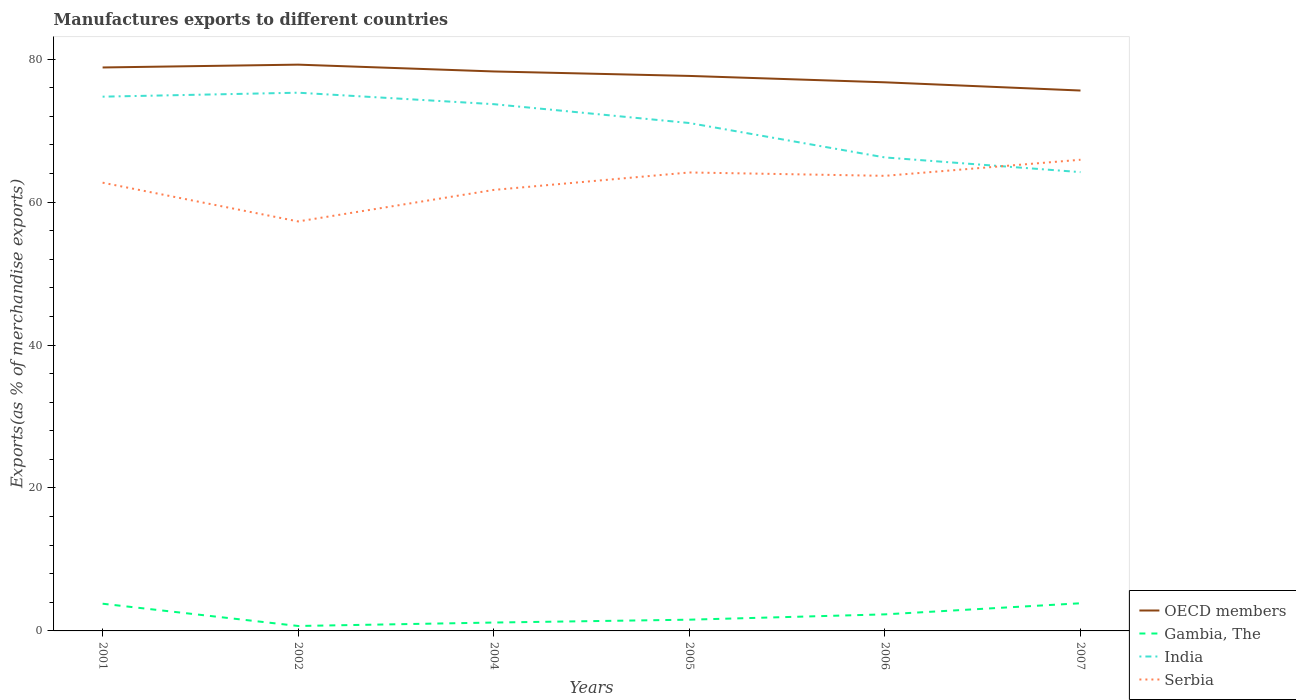Does the line corresponding to Gambia, The intersect with the line corresponding to OECD members?
Your answer should be very brief. No. Across all years, what is the maximum percentage of exports to different countries in India?
Offer a terse response. 64.2. In which year was the percentage of exports to different countries in Serbia maximum?
Keep it short and to the point. 2002. What is the total percentage of exports to different countries in Serbia in the graph?
Provide a succinct answer. -6.38. What is the difference between the highest and the second highest percentage of exports to different countries in Serbia?
Your response must be concise. 8.63. What is the difference between the highest and the lowest percentage of exports to different countries in OECD members?
Make the answer very short. 3. What is the difference between two consecutive major ticks on the Y-axis?
Give a very brief answer. 20. Are the values on the major ticks of Y-axis written in scientific E-notation?
Ensure brevity in your answer.  No. Does the graph contain any zero values?
Offer a very short reply. No. Where does the legend appear in the graph?
Keep it short and to the point. Bottom right. How many legend labels are there?
Keep it short and to the point. 4. What is the title of the graph?
Offer a very short reply. Manufactures exports to different countries. What is the label or title of the X-axis?
Your answer should be very brief. Years. What is the label or title of the Y-axis?
Give a very brief answer. Exports(as % of merchandise exports). What is the Exports(as % of merchandise exports) of OECD members in 2001?
Offer a very short reply. 78.85. What is the Exports(as % of merchandise exports) of Gambia, The in 2001?
Offer a terse response. 3.81. What is the Exports(as % of merchandise exports) of India in 2001?
Give a very brief answer. 74.76. What is the Exports(as % of merchandise exports) in Serbia in 2001?
Keep it short and to the point. 62.73. What is the Exports(as % of merchandise exports) of OECD members in 2002?
Make the answer very short. 79.24. What is the Exports(as % of merchandise exports) of Gambia, The in 2002?
Ensure brevity in your answer.  0.69. What is the Exports(as % of merchandise exports) in India in 2002?
Your answer should be compact. 75.32. What is the Exports(as % of merchandise exports) of Serbia in 2002?
Provide a short and direct response. 57.3. What is the Exports(as % of merchandise exports) of OECD members in 2004?
Your answer should be compact. 78.29. What is the Exports(as % of merchandise exports) in Gambia, The in 2004?
Provide a succinct answer. 1.17. What is the Exports(as % of merchandise exports) of India in 2004?
Offer a very short reply. 73.71. What is the Exports(as % of merchandise exports) of Serbia in 2004?
Keep it short and to the point. 61.71. What is the Exports(as % of merchandise exports) of OECD members in 2005?
Keep it short and to the point. 77.67. What is the Exports(as % of merchandise exports) of Gambia, The in 2005?
Your answer should be very brief. 1.57. What is the Exports(as % of merchandise exports) in India in 2005?
Give a very brief answer. 71.07. What is the Exports(as % of merchandise exports) in Serbia in 2005?
Ensure brevity in your answer.  64.15. What is the Exports(as % of merchandise exports) of OECD members in 2006?
Your answer should be compact. 76.77. What is the Exports(as % of merchandise exports) of Gambia, The in 2006?
Ensure brevity in your answer.  2.32. What is the Exports(as % of merchandise exports) in India in 2006?
Your answer should be very brief. 66.26. What is the Exports(as % of merchandise exports) of Serbia in 2006?
Give a very brief answer. 63.68. What is the Exports(as % of merchandise exports) in OECD members in 2007?
Offer a very short reply. 75.62. What is the Exports(as % of merchandise exports) of Gambia, The in 2007?
Ensure brevity in your answer.  3.87. What is the Exports(as % of merchandise exports) in India in 2007?
Your answer should be compact. 64.2. What is the Exports(as % of merchandise exports) in Serbia in 2007?
Make the answer very short. 65.93. Across all years, what is the maximum Exports(as % of merchandise exports) in OECD members?
Ensure brevity in your answer.  79.24. Across all years, what is the maximum Exports(as % of merchandise exports) in Gambia, The?
Your answer should be compact. 3.87. Across all years, what is the maximum Exports(as % of merchandise exports) in India?
Make the answer very short. 75.32. Across all years, what is the maximum Exports(as % of merchandise exports) in Serbia?
Give a very brief answer. 65.93. Across all years, what is the minimum Exports(as % of merchandise exports) in OECD members?
Provide a short and direct response. 75.62. Across all years, what is the minimum Exports(as % of merchandise exports) of Gambia, The?
Offer a terse response. 0.69. Across all years, what is the minimum Exports(as % of merchandise exports) in India?
Ensure brevity in your answer.  64.2. Across all years, what is the minimum Exports(as % of merchandise exports) in Serbia?
Provide a short and direct response. 57.3. What is the total Exports(as % of merchandise exports) in OECD members in the graph?
Ensure brevity in your answer.  466.44. What is the total Exports(as % of merchandise exports) in Gambia, The in the graph?
Keep it short and to the point. 13.43. What is the total Exports(as % of merchandise exports) of India in the graph?
Your answer should be compact. 425.32. What is the total Exports(as % of merchandise exports) in Serbia in the graph?
Make the answer very short. 375.51. What is the difference between the Exports(as % of merchandise exports) of OECD members in 2001 and that in 2002?
Provide a succinct answer. -0.4. What is the difference between the Exports(as % of merchandise exports) in Gambia, The in 2001 and that in 2002?
Provide a succinct answer. 3.12. What is the difference between the Exports(as % of merchandise exports) in India in 2001 and that in 2002?
Provide a succinct answer. -0.56. What is the difference between the Exports(as % of merchandise exports) of Serbia in 2001 and that in 2002?
Your answer should be very brief. 5.42. What is the difference between the Exports(as % of merchandise exports) in OECD members in 2001 and that in 2004?
Offer a terse response. 0.56. What is the difference between the Exports(as % of merchandise exports) in Gambia, The in 2001 and that in 2004?
Provide a succinct answer. 2.63. What is the difference between the Exports(as % of merchandise exports) of India in 2001 and that in 2004?
Give a very brief answer. 1.05. What is the difference between the Exports(as % of merchandise exports) in Serbia in 2001 and that in 2004?
Provide a succinct answer. 1.01. What is the difference between the Exports(as % of merchandise exports) in OECD members in 2001 and that in 2005?
Offer a terse response. 1.18. What is the difference between the Exports(as % of merchandise exports) in Gambia, The in 2001 and that in 2005?
Your answer should be very brief. 2.23. What is the difference between the Exports(as % of merchandise exports) in India in 2001 and that in 2005?
Provide a succinct answer. 3.69. What is the difference between the Exports(as % of merchandise exports) of Serbia in 2001 and that in 2005?
Make the answer very short. -1.43. What is the difference between the Exports(as % of merchandise exports) in OECD members in 2001 and that in 2006?
Give a very brief answer. 2.08. What is the difference between the Exports(as % of merchandise exports) of Gambia, The in 2001 and that in 2006?
Your response must be concise. 1.49. What is the difference between the Exports(as % of merchandise exports) in India in 2001 and that in 2006?
Provide a short and direct response. 8.5. What is the difference between the Exports(as % of merchandise exports) of Serbia in 2001 and that in 2006?
Your answer should be very brief. -0.96. What is the difference between the Exports(as % of merchandise exports) in OECD members in 2001 and that in 2007?
Offer a very short reply. 3.23. What is the difference between the Exports(as % of merchandise exports) in Gambia, The in 2001 and that in 2007?
Ensure brevity in your answer.  -0.06. What is the difference between the Exports(as % of merchandise exports) of India in 2001 and that in 2007?
Provide a succinct answer. 10.56. What is the difference between the Exports(as % of merchandise exports) of Serbia in 2001 and that in 2007?
Provide a short and direct response. -3.21. What is the difference between the Exports(as % of merchandise exports) of OECD members in 2002 and that in 2004?
Give a very brief answer. 0.95. What is the difference between the Exports(as % of merchandise exports) in Gambia, The in 2002 and that in 2004?
Provide a succinct answer. -0.48. What is the difference between the Exports(as % of merchandise exports) of India in 2002 and that in 2004?
Make the answer very short. 1.61. What is the difference between the Exports(as % of merchandise exports) in Serbia in 2002 and that in 2004?
Your response must be concise. -4.41. What is the difference between the Exports(as % of merchandise exports) in OECD members in 2002 and that in 2005?
Your answer should be very brief. 1.58. What is the difference between the Exports(as % of merchandise exports) in Gambia, The in 2002 and that in 2005?
Give a very brief answer. -0.88. What is the difference between the Exports(as % of merchandise exports) of India in 2002 and that in 2005?
Give a very brief answer. 4.24. What is the difference between the Exports(as % of merchandise exports) of Serbia in 2002 and that in 2005?
Your answer should be compact. -6.85. What is the difference between the Exports(as % of merchandise exports) in OECD members in 2002 and that in 2006?
Keep it short and to the point. 2.47. What is the difference between the Exports(as % of merchandise exports) of Gambia, The in 2002 and that in 2006?
Your answer should be very brief. -1.63. What is the difference between the Exports(as % of merchandise exports) in India in 2002 and that in 2006?
Your answer should be very brief. 9.06. What is the difference between the Exports(as % of merchandise exports) of Serbia in 2002 and that in 2006?
Your answer should be very brief. -6.38. What is the difference between the Exports(as % of merchandise exports) in OECD members in 2002 and that in 2007?
Your answer should be compact. 3.62. What is the difference between the Exports(as % of merchandise exports) of Gambia, The in 2002 and that in 2007?
Provide a succinct answer. -3.18. What is the difference between the Exports(as % of merchandise exports) of India in 2002 and that in 2007?
Ensure brevity in your answer.  11.11. What is the difference between the Exports(as % of merchandise exports) of Serbia in 2002 and that in 2007?
Provide a short and direct response. -8.63. What is the difference between the Exports(as % of merchandise exports) in OECD members in 2004 and that in 2005?
Your answer should be compact. 0.62. What is the difference between the Exports(as % of merchandise exports) in Gambia, The in 2004 and that in 2005?
Make the answer very short. -0.4. What is the difference between the Exports(as % of merchandise exports) in India in 2004 and that in 2005?
Keep it short and to the point. 2.64. What is the difference between the Exports(as % of merchandise exports) of Serbia in 2004 and that in 2005?
Offer a terse response. -2.44. What is the difference between the Exports(as % of merchandise exports) of OECD members in 2004 and that in 2006?
Offer a very short reply. 1.52. What is the difference between the Exports(as % of merchandise exports) in Gambia, The in 2004 and that in 2006?
Provide a short and direct response. -1.15. What is the difference between the Exports(as % of merchandise exports) in India in 2004 and that in 2006?
Offer a very short reply. 7.45. What is the difference between the Exports(as % of merchandise exports) of Serbia in 2004 and that in 2006?
Offer a terse response. -1.97. What is the difference between the Exports(as % of merchandise exports) in OECD members in 2004 and that in 2007?
Your answer should be compact. 2.67. What is the difference between the Exports(as % of merchandise exports) in Gambia, The in 2004 and that in 2007?
Ensure brevity in your answer.  -2.7. What is the difference between the Exports(as % of merchandise exports) in India in 2004 and that in 2007?
Your answer should be compact. 9.51. What is the difference between the Exports(as % of merchandise exports) in Serbia in 2004 and that in 2007?
Offer a terse response. -4.22. What is the difference between the Exports(as % of merchandise exports) in OECD members in 2005 and that in 2006?
Your response must be concise. 0.89. What is the difference between the Exports(as % of merchandise exports) in Gambia, The in 2005 and that in 2006?
Make the answer very short. -0.75. What is the difference between the Exports(as % of merchandise exports) in India in 2005 and that in 2006?
Make the answer very short. 4.82. What is the difference between the Exports(as % of merchandise exports) in Serbia in 2005 and that in 2006?
Your answer should be compact. 0.47. What is the difference between the Exports(as % of merchandise exports) in OECD members in 2005 and that in 2007?
Your answer should be very brief. 2.04. What is the difference between the Exports(as % of merchandise exports) in Gambia, The in 2005 and that in 2007?
Your response must be concise. -2.3. What is the difference between the Exports(as % of merchandise exports) of India in 2005 and that in 2007?
Ensure brevity in your answer.  6.87. What is the difference between the Exports(as % of merchandise exports) of Serbia in 2005 and that in 2007?
Keep it short and to the point. -1.78. What is the difference between the Exports(as % of merchandise exports) in OECD members in 2006 and that in 2007?
Keep it short and to the point. 1.15. What is the difference between the Exports(as % of merchandise exports) of Gambia, The in 2006 and that in 2007?
Your answer should be very brief. -1.55. What is the difference between the Exports(as % of merchandise exports) of India in 2006 and that in 2007?
Keep it short and to the point. 2.05. What is the difference between the Exports(as % of merchandise exports) in Serbia in 2006 and that in 2007?
Ensure brevity in your answer.  -2.25. What is the difference between the Exports(as % of merchandise exports) in OECD members in 2001 and the Exports(as % of merchandise exports) in Gambia, The in 2002?
Provide a short and direct response. 78.16. What is the difference between the Exports(as % of merchandise exports) of OECD members in 2001 and the Exports(as % of merchandise exports) of India in 2002?
Provide a succinct answer. 3.53. What is the difference between the Exports(as % of merchandise exports) in OECD members in 2001 and the Exports(as % of merchandise exports) in Serbia in 2002?
Ensure brevity in your answer.  21.54. What is the difference between the Exports(as % of merchandise exports) in Gambia, The in 2001 and the Exports(as % of merchandise exports) in India in 2002?
Provide a succinct answer. -71.51. What is the difference between the Exports(as % of merchandise exports) of Gambia, The in 2001 and the Exports(as % of merchandise exports) of Serbia in 2002?
Give a very brief answer. -53.5. What is the difference between the Exports(as % of merchandise exports) in India in 2001 and the Exports(as % of merchandise exports) in Serbia in 2002?
Keep it short and to the point. 17.46. What is the difference between the Exports(as % of merchandise exports) in OECD members in 2001 and the Exports(as % of merchandise exports) in Gambia, The in 2004?
Provide a succinct answer. 77.67. What is the difference between the Exports(as % of merchandise exports) in OECD members in 2001 and the Exports(as % of merchandise exports) in India in 2004?
Your response must be concise. 5.13. What is the difference between the Exports(as % of merchandise exports) in OECD members in 2001 and the Exports(as % of merchandise exports) in Serbia in 2004?
Provide a short and direct response. 17.13. What is the difference between the Exports(as % of merchandise exports) in Gambia, The in 2001 and the Exports(as % of merchandise exports) in India in 2004?
Your answer should be compact. -69.9. What is the difference between the Exports(as % of merchandise exports) in Gambia, The in 2001 and the Exports(as % of merchandise exports) in Serbia in 2004?
Your answer should be compact. -57.91. What is the difference between the Exports(as % of merchandise exports) in India in 2001 and the Exports(as % of merchandise exports) in Serbia in 2004?
Offer a very short reply. 13.05. What is the difference between the Exports(as % of merchandise exports) in OECD members in 2001 and the Exports(as % of merchandise exports) in Gambia, The in 2005?
Keep it short and to the point. 77.27. What is the difference between the Exports(as % of merchandise exports) in OECD members in 2001 and the Exports(as % of merchandise exports) in India in 2005?
Provide a short and direct response. 7.77. What is the difference between the Exports(as % of merchandise exports) of OECD members in 2001 and the Exports(as % of merchandise exports) of Serbia in 2005?
Give a very brief answer. 14.69. What is the difference between the Exports(as % of merchandise exports) in Gambia, The in 2001 and the Exports(as % of merchandise exports) in India in 2005?
Offer a terse response. -67.27. What is the difference between the Exports(as % of merchandise exports) of Gambia, The in 2001 and the Exports(as % of merchandise exports) of Serbia in 2005?
Make the answer very short. -60.35. What is the difference between the Exports(as % of merchandise exports) in India in 2001 and the Exports(as % of merchandise exports) in Serbia in 2005?
Offer a very short reply. 10.61. What is the difference between the Exports(as % of merchandise exports) of OECD members in 2001 and the Exports(as % of merchandise exports) of Gambia, The in 2006?
Keep it short and to the point. 76.53. What is the difference between the Exports(as % of merchandise exports) in OECD members in 2001 and the Exports(as % of merchandise exports) in India in 2006?
Your answer should be very brief. 12.59. What is the difference between the Exports(as % of merchandise exports) of OECD members in 2001 and the Exports(as % of merchandise exports) of Serbia in 2006?
Your response must be concise. 15.16. What is the difference between the Exports(as % of merchandise exports) in Gambia, The in 2001 and the Exports(as % of merchandise exports) in India in 2006?
Keep it short and to the point. -62.45. What is the difference between the Exports(as % of merchandise exports) of Gambia, The in 2001 and the Exports(as % of merchandise exports) of Serbia in 2006?
Ensure brevity in your answer.  -59.88. What is the difference between the Exports(as % of merchandise exports) of India in 2001 and the Exports(as % of merchandise exports) of Serbia in 2006?
Offer a terse response. 11.08. What is the difference between the Exports(as % of merchandise exports) of OECD members in 2001 and the Exports(as % of merchandise exports) of Gambia, The in 2007?
Ensure brevity in your answer.  74.98. What is the difference between the Exports(as % of merchandise exports) of OECD members in 2001 and the Exports(as % of merchandise exports) of India in 2007?
Your answer should be compact. 14.64. What is the difference between the Exports(as % of merchandise exports) in OECD members in 2001 and the Exports(as % of merchandise exports) in Serbia in 2007?
Ensure brevity in your answer.  12.91. What is the difference between the Exports(as % of merchandise exports) in Gambia, The in 2001 and the Exports(as % of merchandise exports) in India in 2007?
Give a very brief answer. -60.4. What is the difference between the Exports(as % of merchandise exports) in Gambia, The in 2001 and the Exports(as % of merchandise exports) in Serbia in 2007?
Offer a very short reply. -62.13. What is the difference between the Exports(as % of merchandise exports) in India in 2001 and the Exports(as % of merchandise exports) in Serbia in 2007?
Give a very brief answer. 8.83. What is the difference between the Exports(as % of merchandise exports) of OECD members in 2002 and the Exports(as % of merchandise exports) of Gambia, The in 2004?
Your answer should be very brief. 78.07. What is the difference between the Exports(as % of merchandise exports) of OECD members in 2002 and the Exports(as % of merchandise exports) of India in 2004?
Ensure brevity in your answer.  5.53. What is the difference between the Exports(as % of merchandise exports) of OECD members in 2002 and the Exports(as % of merchandise exports) of Serbia in 2004?
Give a very brief answer. 17.53. What is the difference between the Exports(as % of merchandise exports) in Gambia, The in 2002 and the Exports(as % of merchandise exports) in India in 2004?
Provide a succinct answer. -73.02. What is the difference between the Exports(as % of merchandise exports) of Gambia, The in 2002 and the Exports(as % of merchandise exports) of Serbia in 2004?
Provide a succinct answer. -61.02. What is the difference between the Exports(as % of merchandise exports) in India in 2002 and the Exports(as % of merchandise exports) in Serbia in 2004?
Keep it short and to the point. 13.6. What is the difference between the Exports(as % of merchandise exports) of OECD members in 2002 and the Exports(as % of merchandise exports) of Gambia, The in 2005?
Ensure brevity in your answer.  77.67. What is the difference between the Exports(as % of merchandise exports) in OECD members in 2002 and the Exports(as % of merchandise exports) in India in 2005?
Offer a terse response. 8.17. What is the difference between the Exports(as % of merchandise exports) in OECD members in 2002 and the Exports(as % of merchandise exports) in Serbia in 2005?
Provide a succinct answer. 15.09. What is the difference between the Exports(as % of merchandise exports) of Gambia, The in 2002 and the Exports(as % of merchandise exports) of India in 2005?
Provide a short and direct response. -70.38. What is the difference between the Exports(as % of merchandise exports) in Gambia, The in 2002 and the Exports(as % of merchandise exports) in Serbia in 2005?
Provide a succinct answer. -63.46. What is the difference between the Exports(as % of merchandise exports) of India in 2002 and the Exports(as % of merchandise exports) of Serbia in 2005?
Your response must be concise. 11.16. What is the difference between the Exports(as % of merchandise exports) in OECD members in 2002 and the Exports(as % of merchandise exports) in Gambia, The in 2006?
Offer a terse response. 76.93. What is the difference between the Exports(as % of merchandise exports) in OECD members in 2002 and the Exports(as % of merchandise exports) in India in 2006?
Provide a short and direct response. 12.99. What is the difference between the Exports(as % of merchandise exports) of OECD members in 2002 and the Exports(as % of merchandise exports) of Serbia in 2006?
Make the answer very short. 15.56. What is the difference between the Exports(as % of merchandise exports) of Gambia, The in 2002 and the Exports(as % of merchandise exports) of India in 2006?
Give a very brief answer. -65.57. What is the difference between the Exports(as % of merchandise exports) of Gambia, The in 2002 and the Exports(as % of merchandise exports) of Serbia in 2006?
Make the answer very short. -62.99. What is the difference between the Exports(as % of merchandise exports) of India in 2002 and the Exports(as % of merchandise exports) of Serbia in 2006?
Provide a succinct answer. 11.63. What is the difference between the Exports(as % of merchandise exports) in OECD members in 2002 and the Exports(as % of merchandise exports) in Gambia, The in 2007?
Ensure brevity in your answer.  75.37. What is the difference between the Exports(as % of merchandise exports) in OECD members in 2002 and the Exports(as % of merchandise exports) in India in 2007?
Your response must be concise. 15.04. What is the difference between the Exports(as % of merchandise exports) of OECD members in 2002 and the Exports(as % of merchandise exports) of Serbia in 2007?
Offer a very short reply. 13.31. What is the difference between the Exports(as % of merchandise exports) in Gambia, The in 2002 and the Exports(as % of merchandise exports) in India in 2007?
Your answer should be compact. -63.51. What is the difference between the Exports(as % of merchandise exports) in Gambia, The in 2002 and the Exports(as % of merchandise exports) in Serbia in 2007?
Provide a short and direct response. -65.24. What is the difference between the Exports(as % of merchandise exports) in India in 2002 and the Exports(as % of merchandise exports) in Serbia in 2007?
Keep it short and to the point. 9.38. What is the difference between the Exports(as % of merchandise exports) in OECD members in 2004 and the Exports(as % of merchandise exports) in Gambia, The in 2005?
Ensure brevity in your answer.  76.72. What is the difference between the Exports(as % of merchandise exports) in OECD members in 2004 and the Exports(as % of merchandise exports) in India in 2005?
Provide a succinct answer. 7.21. What is the difference between the Exports(as % of merchandise exports) of OECD members in 2004 and the Exports(as % of merchandise exports) of Serbia in 2005?
Make the answer very short. 14.13. What is the difference between the Exports(as % of merchandise exports) of Gambia, The in 2004 and the Exports(as % of merchandise exports) of India in 2005?
Make the answer very short. -69.9. What is the difference between the Exports(as % of merchandise exports) of Gambia, The in 2004 and the Exports(as % of merchandise exports) of Serbia in 2005?
Offer a very short reply. -62.98. What is the difference between the Exports(as % of merchandise exports) in India in 2004 and the Exports(as % of merchandise exports) in Serbia in 2005?
Offer a terse response. 9.56. What is the difference between the Exports(as % of merchandise exports) of OECD members in 2004 and the Exports(as % of merchandise exports) of Gambia, The in 2006?
Offer a terse response. 75.97. What is the difference between the Exports(as % of merchandise exports) of OECD members in 2004 and the Exports(as % of merchandise exports) of India in 2006?
Provide a short and direct response. 12.03. What is the difference between the Exports(as % of merchandise exports) of OECD members in 2004 and the Exports(as % of merchandise exports) of Serbia in 2006?
Provide a succinct answer. 14.61. What is the difference between the Exports(as % of merchandise exports) in Gambia, The in 2004 and the Exports(as % of merchandise exports) in India in 2006?
Provide a succinct answer. -65.08. What is the difference between the Exports(as % of merchandise exports) of Gambia, The in 2004 and the Exports(as % of merchandise exports) of Serbia in 2006?
Provide a short and direct response. -62.51. What is the difference between the Exports(as % of merchandise exports) of India in 2004 and the Exports(as % of merchandise exports) of Serbia in 2006?
Keep it short and to the point. 10.03. What is the difference between the Exports(as % of merchandise exports) in OECD members in 2004 and the Exports(as % of merchandise exports) in Gambia, The in 2007?
Your answer should be compact. 74.42. What is the difference between the Exports(as % of merchandise exports) in OECD members in 2004 and the Exports(as % of merchandise exports) in India in 2007?
Offer a very short reply. 14.09. What is the difference between the Exports(as % of merchandise exports) of OECD members in 2004 and the Exports(as % of merchandise exports) of Serbia in 2007?
Your answer should be compact. 12.36. What is the difference between the Exports(as % of merchandise exports) of Gambia, The in 2004 and the Exports(as % of merchandise exports) of India in 2007?
Your answer should be compact. -63.03. What is the difference between the Exports(as % of merchandise exports) in Gambia, The in 2004 and the Exports(as % of merchandise exports) in Serbia in 2007?
Your response must be concise. -64.76. What is the difference between the Exports(as % of merchandise exports) of India in 2004 and the Exports(as % of merchandise exports) of Serbia in 2007?
Offer a very short reply. 7.78. What is the difference between the Exports(as % of merchandise exports) of OECD members in 2005 and the Exports(as % of merchandise exports) of Gambia, The in 2006?
Offer a terse response. 75.35. What is the difference between the Exports(as % of merchandise exports) of OECD members in 2005 and the Exports(as % of merchandise exports) of India in 2006?
Provide a succinct answer. 11.41. What is the difference between the Exports(as % of merchandise exports) in OECD members in 2005 and the Exports(as % of merchandise exports) in Serbia in 2006?
Your answer should be compact. 13.98. What is the difference between the Exports(as % of merchandise exports) in Gambia, The in 2005 and the Exports(as % of merchandise exports) in India in 2006?
Your answer should be very brief. -64.68. What is the difference between the Exports(as % of merchandise exports) of Gambia, The in 2005 and the Exports(as % of merchandise exports) of Serbia in 2006?
Make the answer very short. -62.11. What is the difference between the Exports(as % of merchandise exports) of India in 2005 and the Exports(as % of merchandise exports) of Serbia in 2006?
Your answer should be compact. 7.39. What is the difference between the Exports(as % of merchandise exports) in OECD members in 2005 and the Exports(as % of merchandise exports) in Gambia, The in 2007?
Ensure brevity in your answer.  73.79. What is the difference between the Exports(as % of merchandise exports) of OECD members in 2005 and the Exports(as % of merchandise exports) of India in 2007?
Provide a short and direct response. 13.46. What is the difference between the Exports(as % of merchandise exports) in OECD members in 2005 and the Exports(as % of merchandise exports) in Serbia in 2007?
Offer a terse response. 11.73. What is the difference between the Exports(as % of merchandise exports) of Gambia, The in 2005 and the Exports(as % of merchandise exports) of India in 2007?
Provide a short and direct response. -62.63. What is the difference between the Exports(as % of merchandise exports) of Gambia, The in 2005 and the Exports(as % of merchandise exports) of Serbia in 2007?
Your response must be concise. -64.36. What is the difference between the Exports(as % of merchandise exports) in India in 2005 and the Exports(as % of merchandise exports) in Serbia in 2007?
Ensure brevity in your answer.  5.14. What is the difference between the Exports(as % of merchandise exports) in OECD members in 2006 and the Exports(as % of merchandise exports) in Gambia, The in 2007?
Offer a terse response. 72.9. What is the difference between the Exports(as % of merchandise exports) in OECD members in 2006 and the Exports(as % of merchandise exports) in India in 2007?
Provide a short and direct response. 12.57. What is the difference between the Exports(as % of merchandise exports) of OECD members in 2006 and the Exports(as % of merchandise exports) of Serbia in 2007?
Provide a short and direct response. 10.84. What is the difference between the Exports(as % of merchandise exports) in Gambia, The in 2006 and the Exports(as % of merchandise exports) in India in 2007?
Make the answer very short. -61.88. What is the difference between the Exports(as % of merchandise exports) of Gambia, The in 2006 and the Exports(as % of merchandise exports) of Serbia in 2007?
Ensure brevity in your answer.  -63.62. What is the difference between the Exports(as % of merchandise exports) of India in 2006 and the Exports(as % of merchandise exports) of Serbia in 2007?
Provide a succinct answer. 0.32. What is the average Exports(as % of merchandise exports) of OECD members per year?
Keep it short and to the point. 77.74. What is the average Exports(as % of merchandise exports) of Gambia, The per year?
Offer a very short reply. 2.24. What is the average Exports(as % of merchandise exports) in India per year?
Make the answer very short. 70.89. What is the average Exports(as % of merchandise exports) of Serbia per year?
Offer a terse response. 62.59. In the year 2001, what is the difference between the Exports(as % of merchandise exports) of OECD members and Exports(as % of merchandise exports) of Gambia, The?
Ensure brevity in your answer.  75.04. In the year 2001, what is the difference between the Exports(as % of merchandise exports) in OECD members and Exports(as % of merchandise exports) in India?
Give a very brief answer. 4.09. In the year 2001, what is the difference between the Exports(as % of merchandise exports) of OECD members and Exports(as % of merchandise exports) of Serbia?
Provide a short and direct response. 16.12. In the year 2001, what is the difference between the Exports(as % of merchandise exports) in Gambia, The and Exports(as % of merchandise exports) in India?
Provide a succinct answer. -70.95. In the year 2001, what is the difference between the Exports(as % of merchandise exports) of Gambia, The and Exports(as % of merchandise exports) of Serbia?
Offer a very short reply. -58.92. In the year 2001, what is the difference between the Exports(as % of merchandise exports) of India and Exports(as % of merchandise exports) of Serbia?
Offer a very short reply. 12.04. In the year 2002, what is the difference between the Exports(as % of merchandise exports) in OECD members and Exports(as % of merchandise exports) in Gambia, The?
Provide a short and direct response. 78.55. In the year 2002, what is the difference between the Exports(as % of merchandise exports) of OECD members and Exports(as % of merchandise exports) of India?
Offer a very short reply. 3.93. In the year 2002, what is the difference between the Exports(as % of merchandise exports) of OECD members and Exports(as % of merchandise exports) of Serbia?
Your response must be concise. 21.94. In the year 2002, what is the difference between the Exports(as % of merchandise exports) of Gambia, The and Exports(as % of merchandise exports) of India?
Give a very brief answer. -74.63. In the year 2002, what is the difference between the Exports(as % of merchandise exports) of Gambia, The and Exports(as % of merchandise exports) of Serbia?
Ensure brevity in your answer.  -56.61. In the year 2002, what is the difference between the Exports(as % of merchandise exports) of India and Exports(as % of merchandise exports) of Serbia?
Your answer should be compact. 18.01. In the year 2004, what is the difference between the Exports(as % of merchandise exports) in OECD members and Exports(as % of merchandise exports) in Gambia, The?
Keep it short and to the point. 77.12. In the year 2004, what is the difference between the Exports(as % of merchandise exports) in OECD members and Exports(as % of merchandise exports) in India?
Give a very brief answer. 4.58. In the year 2004, what is the difference between the Exports(as % of merchandise exports) of OECD members and Exports(as % of merchandise exports) of Serbia?
Your response must be concise. 16.58. In the year 2004, what is the difference between the Exports(as % of merchandise exports) of Gambia, The and Exports(as % of merchandise exports) of India?
Provide a short and direct response. -72.54. In the year 2004, what is the difference between the Exports(as % of merchandise exports) of Gambia, The and Exports(as % of merchandise exports) of Serbia?
Offer a terse response. -60.54. In the year 2004, what is the difference between the Exports(as % of merchandise exports) of India and Exports(as % of merchandise exports) of Serbia?
Your response must be concise. 12. In the year 2005, what is the difference between the Exports(as % of merchandise exports) in OECD members and Exports(as % of merchandise exports) in Gambia, The?
Your answer should be very brief. 76.09. In the year 2005, what is the difference between the Exports(as % of merchandise exports) of OECD members and Exports(as % of merchandise exports) of India?
Give a very brief answer. 6.59. In the year 2005, what is the difference between the Exports(as % of merchandise exports) of OECD members and Exports(as % of merchandise exports) of Serbia?
Offer a very short reply. 13.51. In the year 2005, what is the difference between the Exports(as % of merchandise exports) of Gambia, The and Exports(as % of merchandise exports) of India?
Keep it short and to the point. -69.5. In the year 2005, what is the difference between the Exports(as % of merchandise exports) in Gambia, The and Exports(as % of merchandise exports) in Serbia?
Your answer should be very brief. -62.58. In the year 2005, what is the difference between the Exports(as % of merchandise exports) of India and Exports(as % of merchandise exports) of Serbia?
Your response must be concise. 6.92. In the year 2006, what is the difference between the Exports(as % of merchandise exports) in OECD members and Exports(as % of merchandise exports) in Gambia, The?
Your response must be concise. 74.45. In the year 2006, what is the difference between the Exports(as % of merchandise exports) of OECD members and Exports(as % of merchandise exports) of India?
Your answer should be very brief. 10.51. In the year 2006, what is the difference between the Exports(as % of merchandise exports) of OECD members and Exports(as % of merchandise exports) of Serbia?
Your answer should be compact. 13.09. In the year 2006, what is the difference between the Exports(as % of merchandise exports) of Gambia, The and Exports(as % of merchandise exports) of India?
Your response must be concise. -63.94. In the year 2006, what is the difference between the Exports(as % of merchandise exports) in Gambia, The and Exports(as % of merchandise exports) in Serbia?
Offer a very short reply. -61.37. In the year 2006, what is the difference between the Exports(as % of merchandise exports) in India and Exports(as % of merchandise exports) in Serbia?
Offer a very short reply. 2.57. In the year 2007, what is the difference between the Exports(as % of merchandise exports) of OECD members and Exports(as % of merchandise exports) of Gambia, The?
Give a very brief answer. 71.75. In the year 2007, what is the difference between the Exports(as % of merchandise exports) of OECD members and Exports(as % of merchandise exports) of India?
Provide a short and direct response. 11.42. In the year 2007, what is the difference between the Exports(as % of merchandise exports) in OECD members and Exports(as % of merchandise exports) in Serbia?
Keep it short and to the point. 9.69. In the year 2007, what is the difference between the Exports(as % of merchandise exports) in Gambia, The and Exports(as % of merchandise exports) in India?
Your answer should be very brief. -60.33. In the year 2007, what is the difference between the Exports(as % of merchandise exports) in Gambia, The and Exports(as % of merchandise exports) in Serbia?
Offer a very short reply. -62.06. In the year 2007, what is the difference between the Exports(as % of merchandise exports) in India and Exports(as % of merchandise exports) in Serbia?
Your answer should be compact. -1.73. What is the ratio of the Exports(as % of merchandise exports) in OECD members in 2001 to that in 2002?
Keep it short and to the point. 0.99. What is the ratio of the Exports(as % of merchandise exports) of Gambia, The in 2001 to that in 2002?
Your response must be concise. 5.51. What is the ratio of the Exports(as % of merchandise exports) of Serbia in 2001 to that in 2002?
Your answer should be very brief. 1.09. What is the ratio of the Exports(as % of merchandise exports) in OECD members in 2001 to that in 2004?
Make the answer very short. 1.01. What is the ratio of the Exports(as % of merchandise exports) of Gambia, The in 2001 to that in 2004?
Offer a very short reply. 3.25. What is the ratio of the Exports(as % of merchandise exports) in India in 2001 to that in 2004?
Keep it short and to the point. 1.01. What is the ratio of the Exports(as % of merchandise exports) of Serbia in 2001 to that in 2004?
Your answer should be compact. 1.02. What is the ratio of the Exports(as % of merchandise exports) in OECD members in 2001 to that in 2005?
Your answer should be compact. 1.02. What is the ratio of the Exports(as % of merchandise exports) in Gambia, The in 2001 to that in 2005?
Your answer should be very brief. 2.42. What is the ratio of the Exports(as % of merchandise exports) in India in 2001 to that in 2005?
Offer a terse response. 1.05. What is the ratio of the Exports(as % of merchandise exports) of Serbia in 2001 to that in 2005?
Your answer should be very brief. 0.98. What is the ratio of the Exports(as % of merchandise exports) of Gambia, The in 2001 to that in 2006?
Make the answer very short. 1.64. What is the ratio of the Exports(as % of merchandise exports) in India in 2001 to that in 2006?
Give a very brief answer. 1.13. What is the ratio of the Exports(as % of merchandise exports) in Serbia in 2001 to that in 2006?
Your response must be concise. 0.98. What is the ratio of the Exports(as % of merchandise exports) in OECD members in 2001 to that in 2007?
Your answer should be compact. 1.04. What is the ratio of the Exports(as % of merchandise exports) of Gambia, The in 2001 to that in 2007?
Provide a short and direct response. 0.98. What is the ratio of the Exports(as % of merchandise exports) of India in 2001 to that in 2007?
Make the answer very short. 1.16. What is the ratio of the Exports(as % of merchandise exports) of Serbia in 2001 to that in 2007?
Keep it short and to the point. 0.95. What is the ratio of the Exports(as % of merchandise exports) of OECD members in 2002 to that in 2004?
Give a very brief answer. 1.01. What is the ratio of the Exports(as % of merchandise exports) in Gambia, The in 2002 to that in 2004?
Provide a short and direct response. 0.59. What is the ratio of the Exports(as % of merchandise exports) of India in 2002 to that in 2004?
Offer a terse response. 1.02. What is the ratio of the Exports(as % of merchandise exports) in Serbia in 2002 to that in 2004?
Your answer should be very brief. 0.93. What is the ratio of the Exports(as % of merchandise exports) of OECD members in 2002 to that in 2005?
Offer a terse response. 1.02. What is the ratio of the Exports(as % of merchandise exports) of Gambia, The in 2002 to that in 2005?
Provide a succinct answer. 0.44. What is the ratio of the Exports(as % of merchandise exports) in India in 2002 to that in 2005?
Provide a short and direct response. 1.06. What is the ratio of the Exports(as % of merchandise exports) in Serbia in 2002 to that in 2005?
Provide a succinct answer. 0.89. What is the ratio of the Exports(as % of merchandise exports) in OECD members in 2002 to that in 2006?
Your answer should be very brief. 1.03. What is the ratio of the Exports(as % of merchandise exports) of Gambia, The in 2002 to that in 2006?
Make the answer very short. 0.3. What is the ratio of the Exports(as % of merchandise exports) of India in 2002 to that in 2006?
Provide a short and direct response. 1.14. What is the ratio of the Exports(as % of merchandise exports) in Serbia in 2002 to that in 2006?
Make the answer very short. 0.9. What is the ratio of the Exports(as % of merchandise exports) in OECD members in 2002 to that in 2007?
Offer a very short reply. 1.05. What is the ratio of the Exports(as % of merchandise exports) of Gambia, The in 2002 to that in 2007?
Provide a succinct answer. 0.18. What is the ratio of the Exports(as % of merchandise exports) in India in 2002 to that in 2007?
Provide a succinct answer. 1.17. What is the ratio of the Exports(as % of merchandise exports) of Serbia in 2002 to that in 2007?
Provide a short and direct response. 0.87. What is the ratio of the Exports(as % of merchandise exports) of Gambia, The in 2004 to that in 2005?
Your answer should be very brief. 0.75. What is the ratio of the Exports(as % of merchandise exports) in India in 2004 to that in 2005?
Provide a succinct answer. 1.04. What is the ratio of the Exports(as % of merchandise exports) in Serbia in 2004 to that in 2005?
Keep it short and to the point. 0.96. What is the ratio of the Exports(as % of merchandise exports) in OECD members in 2004 to that in 2006?
Keep it short and to the point. 1.02. What is the ratio of the Exports(as % of merchandise exports) in Gambia, The in 2004 to that in 2006?
Provide a short and direct response. 0.51. What is the ratio of the Exports(as % of merchandise exports) of India in 2004 to that in 2006?
Offer a very short reply. 1.11. What is the ratio of the Exports(as % of merchandise exports) of Serbia in 2004 to that in 2006?
Offer a very short reply. 0.97. What is the ratio of the Exports(as % of merchandise exports) of OECD members in 2004 to that in 2007?
Provide a succinct answer. 1.04. What is the ratio of the Exports(as % of merchandise exports) in Gambia, The in 2004 to that in 2007?
Your answer should be very brief. 0.3. What is the ratio of the Exports(as % of merchandise exports) of India in 2004 to that in 2007?
Provide a short and direct response. 1.15. What is the ratio of the Exports(as % of merchandise exports) of Serbia in 2004 to that in 2007?
Give a very brief answer. 0.94. What is the ratio of the Exports(as % of merchandise exports) of OECD members in 2005 to that in 2006?
Your answer should be compact. 1.01. What is the ratio of the Exports(as % of merchandise exports) in Gambia, The in 2005 to that in 2006?
Keep it short and to the point. 0.68. What is the ratio of the Exports(as % of merchandise exports) in India in 2005 to that in 2006?
Give a very brief answer. 1.07. What is the ratio of the Exports(as % of merchandise exports) in Serbia in 2005 to that in 2006?
Give a very brief answer. 1.01. What is the ratio of the Exports(as % of merchandise exports) of OECD members in 2005 to that in 2007?
Give a very brief answer. 1.03. What is the ratio of the Exports(as % of merchandise exports) of Gambia, The in 2005 to that in 2007?
Offer a very short reply. 0.41. What is the ratio of the Exports(as % of merchandise exports) in India in 2005 to that in 2007?
Ensure brevity in your answer.  1.11. What is the ratio of the Exports(as % of merchandise exports) in OECD members in 2006 to that in 2007?
Provide a short and direct response. 1.02. What is the ratio of the Exports(as % of merchandise exports) of Gambia, The in 2006 to that in 2007?
Make the answer very short. 0.6. What is the ratio of the Exports(as % of merchandise exports) of India in 2006 to that in 2007?
Provide a succinct answer. 1.03. What is the ratio of the Exports(as % of merchandise exports) of Serbia in 2006 to that in 2007?
Keep it short and to the point. 0.97. What is the difference between the highest and the second highest Exports(as % of merchandise exports) of OECD members?
Your answer should be compact. 0.4. What is the difference between the highest and the second highest Exports(as % of merchandise exports) of Gambia, The?
Ensure brevity in your answer.  0.06. What is the difference between the highest and the second highest Exports(as % of merchandise exports) in India?
Give a very brief answer. 0.56. What is the difference between the highest and the second highest Exports(as % of merchandise exports) in Serbia?
Your answer should be very brief. 1.78. What is the difference between the highest and the lowest Exports(as % of merchandise exports) in OECD members?
Keep it short and to the point. 3.62. What is the difference between the highest and the lowest Exports(as % of merchandise exports) in Gambia, The?
Give a very brief answer. 3.18. What is the difference between the highest and the lowest Exports(as % of merchandise exports) in India?
Your response must be concise. 11.11. What is the difference between the highest and the lowest Exports(as % of merchandise exports) of Serbia?
Your answer should be very brief. 8.63. 